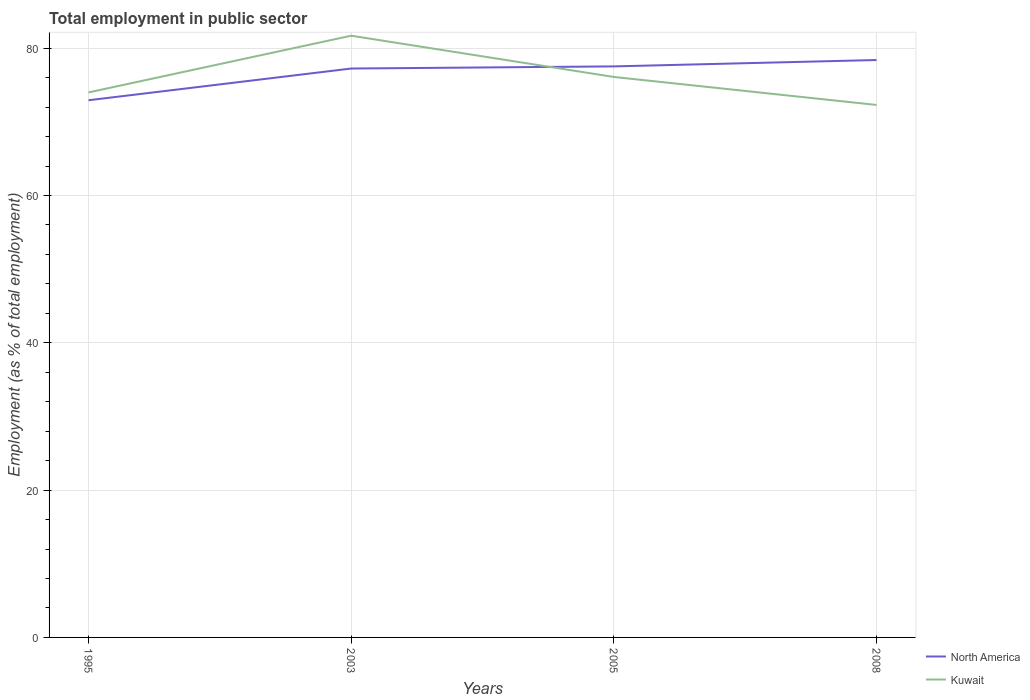Across all years, what is the maximum employment in public sector in North America?
Provide a short and direct response. 72.94. What is the total employment in public sector in North America in the graph?
Ensure brevity in your answer.  -1.16. What is the difference between the highest and the second highest employment in public sector in Kuwait?
Your response must be concise. 9.4. What is the difference between the highest and the lowest employment in public sector in North America?
Ensure brevity in your answer.  3. Is the employment in public sector in Kuwait strictly greater than the employment in public sector in North America over the years?
Your response must be concise. No. What is the difference between two consecutive major ticks on the Y-axis?
Make the answer very short. 20. Are the values on the major ticks of Y-axis written in scientific E-notation?
Provide a succinct answer. No. Does the graph contain any zero values?
Offer a very short reply. No. Does the graph contain grids?
Your response must be concise. Yes. Where does the legend appear in the graph?
Offer a very short reply. Bottom right. How many legend labels are there?
Provide a short and direct response. 2. What is the title of the graph?
Make the answer very short. Total employment in public sector. Does "Indonesia" appear as one of the legend labels in the graph?
Your answer should be compact. No. What is the label or title of the X-axis?
Offer a very short reply. Years. What is the label or title of the Y-axis?
Provide a short and direct response. Employment (as % of total employment). What is the Employment (as % of total employment) of North America in 1995?
Make the answer very short. 72.94. What is the Employment (as % of total employment) in Kuwait in 1995?
Give a very brief answer. 74. What is the Employment (as % of total employment) in North America in 2003?
Provide a short and direct response. 77.24. What is the Employment (as % of total employment) in Kuwait in 2003?
Your answer should be compact. 81.7. What is the Employment (as % of total employment) in North America in 2005?
Your answer should be compact. 77.53. What is the Employment (as % of total employment) in Kuwait in 2005?
Offer a terse response. 76.1. What is the Employment (as % of total employment) of North America in 2008?
Provide a short and direct response. 78.4. What is the Employment (as % of total employment) of Kuwait in 2008?
Offer a terse response. 72.3. Across all years, what is the maximum Employment (as % of total employment) of North America?
Provide a succinct answer. 78.4. Across all years, what is the maximum Employment (as % of total employment) in Kuwait?
Give a very brief answer. 81.7. Across all years, what is the minimum Employment (as % of total employment) in North America?
Keep it short and to the point. 72.94. Across all years, what is the minimum Employment (as % of total employment) of Kuwait?
Make the answer very short. 72.3. What is the total Employment (as % of total employment) in North America in the graph?
Keep it short and to the point. 306.12. What is the total Employment (as % of total employment) in Kuwait in the graph?
Provide a succinct answer. 304.1. What is the difference between the Employment (as % of total employment) in North America in 1995 and that in 2003?
Ensure brevity in your answer.  -4.31. What is the difference between the Employment (as % of total employment) of Kuwait in 1995 and that in 2003?
Your response must be concise. -7.7. What is the difference between the Employment (as % of total employment) of North America in 1995 and that in 2005?
Keep it short and to the point. -4.6. What is the difference between the Employment (as % of total employment) of North America in 1995 and that in 2008?
Provide a short and direct response. -5.46. What is the difference between the Employment (as % of total employment) of North America in 2003 and that in 2005?
Your answer should be very brief. -0.29. What is the difference between the Employment (as % of total employment) in North America in 2003 and that in 2008?
Offer a very short reply. -1.16. What is the difference between the Employment (as % of total employment) in North America in 2005 and that in 2008?
Your answer should be very brief. -0.87. What is the difference between the Employment (as % of total employment) of Kuwait in 2005 and that in 2008?
Make the answer very short. 3.8. What is the difference between the Employment (as % of total employment) of North America in 1995 and the Employment (as % of total employment) of Kuwait in 2003?
Your answer should be very brief. -8.76. What is the difference between the Employment (as % of total employment) of North America in 1995 and the Employment (as % of total employment) of Kuwait in 2005?
Offer a terse response. -3.16. What is the difference between the Employment (as % of total employment) of North America in 1995 and the Employment (as % of total employment) of Kuwait in 2008?
Your response must be concise. 0.64. What is the difference between the Employment (as % of total employment) in North America in 2003 and the Employment (as % of total employment) in Kuwait in 2005?
Your response must be concise. 1.14. What is the difference between the Employment (as % of total employment) of North America in 2003 and the Employment (as % of total employment) of Kuwait in 2008?
Provide a short and direct response. 4.94. What is the difference between the Employment (as % of total employment) in North America in 2005 and the Employment (as % of total employment) in Kuwait in 2008?
Make the answer very short. 5.23. What is the average Employment (as % of total employment) in North America per year?
Provide a succinct answer. 76.53. What is the average Employment (as % of total employment) of Kuwait per year?
Offer a very short reply. 76.03. In the year 1995, what is the difference between the Employment (as % of total employment) in North America and Employment (as % of total employment) in Kuwait?
Your answer should be compact. -1.06. In the year 2003, what is the difference between the Employment (as % of total employment) in North America and Employment (as % of total employment) in Kuwait?
Offer a terse response. -4.46. In the year 2005, what is the difference between the Employment (as % of total employment) in North America and Employment (as % of total employment) in Kuwait?
Offer a very short reply. 1.43. In the year 2008, what is the difference between the Employment (as % of total employment) of North America and Employment (as % of total employment) of Kuwait?
Your answer should be very brief. 6.1. What is the ratio of the Employment (as % of total employment) in North America in 1995 to that in 2003?
Make the answer very short. 0.94. What is the ratio of the Employment (as % of total employment) of Kuwait in 1995 to that in 2003?
Offer a very short reply. 0.91. What is the ratio of the Employment (as % of total employment) in North America in 1995 to that in 2005?
Offer a terse response. 0.94. What is the ratio of the Employment (as % of total employment) in Kuwait in 1995 to that in 2005?
Your answer should be very brief. 0.97. What is the ratio of the Employment (as % of total employment) of North America in 1995 to that in 2008?
Provide a short and direct response. 0.93. What is the ratio of the Employment (as % of total employment) in Kuwait in 1995 to that in 2008?
Your response must be concise. 1.02. What is the ratio of the Employment (as % of total employment) of Kuwait in 2003 to that in 2005?
Your answer should be very brief. 1.07. What is the ratio of the Employment (as % of total employment) of North America in 2003 to that in 2008?
Give a very brief answer. 0.99. What is the ratio of the Employment (as % of total employment) in Kuwait in 2003 to that in 2008?
Your answer should be compact. 1.13. What is the ratio of the Employment (as % of total employment) of North America in 2005 to that in 2008?
Keep it short and to the point. 0.99. What is the ratio of the Employment (as % of total employment) in Kuwait in 2005 to that in 2008?
Provide a succinct answer. 1.05. What is the difference between the highest and the second highest Employment (as % of total employment) in North America?
Ensure brevity in your answer.  0.87. What is the difference between the highest and the second highest Employment (as % of total employment) of Kuwait?
Offer a very short reply. 5.6. What is the difference between the highest and the lowest Employment (as % of total employment) in North America?
Your response must be concise. 5.46. What is the difference between the highest and the lowest Employment (as % of total employment) of Kuwait?
Ensure brevity in your answer.  9.4. 